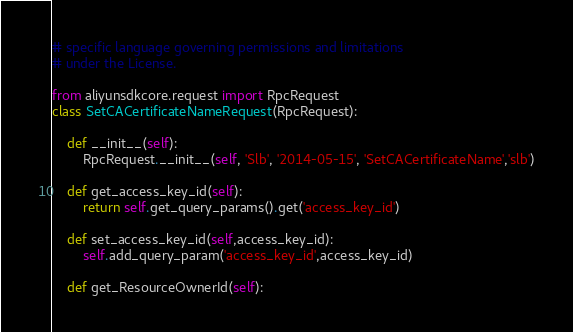<code> <loc_0><loc_0><loc_500><loc_500><_Python_># specific language governing permissions and limitations
# under the License.

from aliyunsdkcore.request import RpcRequest
class SetCACertificateNameRequest(RpcRequest):

	def __init__(self):
		RpcRequest.__init__(self, 'Slb', '2014-05-15', 'SetCACertificateName','slb')

	def get_access_key_id(self):
		return self.get_query_params().get('access_key_id')

	def set_access_key_id(self,access_key_id):
		self.add_query_param('access_key_id',access_key_id)

	def get_ResourceOwnerId(self):</code> 